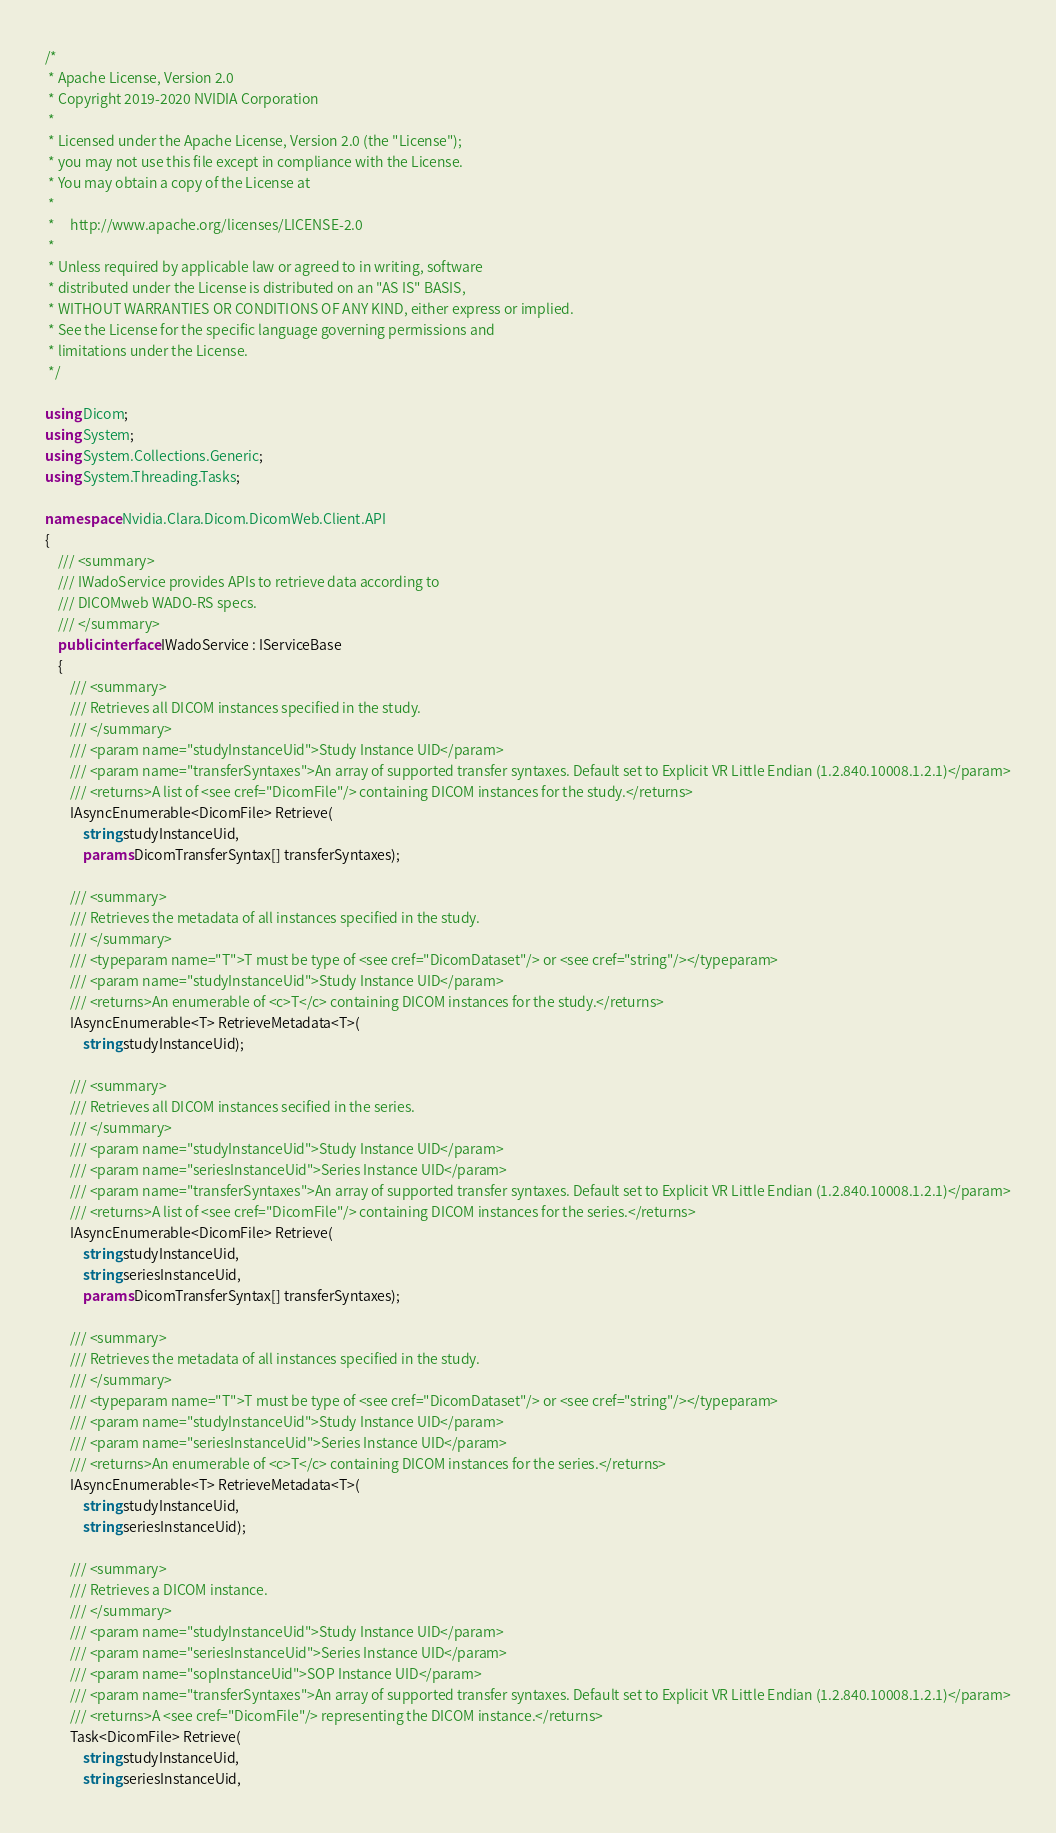<code> <loc_0><loc_0><loc_500><loc_500><_C#_>/*
 * Apache License, Version 2.0
 * Copyright 2019-2020 NVIDIA Corporation
 *
 * Licensed under the Apache License, Version 2.0 (the "License");
 * you may not use this file except in compliance with the License.
 * You may obtain a copy of the License at
 *
 *     http://www.apache.org/licenses/LICENSE-2.0
 *
 * Unless required by applicable law or agreed to in writing, software
 * distributed under the License is distributed on an "AS IS" BASIS,
 * WITHOUT WARRANTIES OR CONDITIONS OF ANY KIND, either express or implied.
 * See the License for the specific language governing permissions and
 * limitations under the License.
 */

using Dicom;
using System;
using System.Collections.Generic;
using System.Threading.Tasks;

namespace Nvidia.Clara.Dicom.DicomWeb.Client.API
{
    /// <summary>
    /// IWadoService provides APIs to retrieve data according to
    /// DICOMweb WADO-RS specs.
    /// </summary>
    public interface IWadoService : IServiceBase
    {
        /// <summary>
        /// Retrieves all DICOM instances specified in the study.
        /// </summary>
        /// <param name="studyInstanceUid">Study Instance UID</param>
        /// <param name="transferSyntaxes">An array of supported transfer syntaxes. Default set to Explicit VR Little Endian (1.2.840.10008.1.2.1)</param>
        /// <returns>A list of <see cref="DicomFile"/> containing DICOM instances for the study.</returns>
        IAsyncEnumerable<DicomFile> Retrieve(
            string studyInstanceUid,
            params DicomTransferSyntax[] transferSyntaxes);

        /// <summary>
        /// Retrieves the metadata of all instances specified in the study.
        /// </summary>
        /// <typeparam name="T">T must be type of <see cref="DicomDataset"/> or <see cref="string"/></typeparam>
        /// <param name="studyInstanceUid">Study Instance UID</param>
        /// <returns>An enumerable of <c>T</c> containing DICOM instances for the study.</returns>
        IAsyncEnumerable<T> RetrieveMetadata<T>(
            string studyInstanceUid);

        /// <summary>
        /// Retrieves all DICOM instances secified in the series.
        /// </summary>
        /// <param name="studyInstanceUid">Study Instance UID</param>
        /// <param name="seriesInstanceUid">Series Instance UID</param>
        /// <param name="transferSyntaxes">An array of supported transfer syntaxes. Default set to Explicit VR Little Endian (1.2.840.10008.1.2.1)</param>
        /// <returns>A list of <see cref="DicomFile"/> containing DICOM instances for the series.</returns>
        IAsyncEnumerable<DicomFile> Retrieve(
            string studyInstanceUid,
            string seriesInstanceUid,
            params DicomTransferSyntax[] transferSyntaxes);

        /// <summary>
        /// Retrieves the metadata of all instances specified in the study.
        /// </summary>
        /// <typeparam name="T">T must be type of <see cref="DicomDataset"/> or <see cref="string"/></typeparam>
        /// <param name="studyInstanceUid">Study Instance UID</param>
        /// <param name="seriesInstanceUid">Series Instance UID</param>
        /// <returns>An enumerable of <c>T</c> containing DICOM instances for the series.</returns>
        IAsyncEnumerable<T> RetrieveMetadata<T>(
            string studyInstanceUid,
            string seriesInstanceUid);

        /// <summary>
        /// Retrieves a DICOM instance.
        /// </summary>
        /// <param name="studyInstanceUid">Study Instance UID</param>
        /// <param name="seriesInstanceUid">Series Instance UID</param>
        /// <param name="sopInstanceUid">SOP Instance UID</param>
        /// <param name="transferSyntaxes">An array of supported transfer syntaxes. Default set to Explicit VR Little Endian (1.2.840.10008.1.2.1)</param>
        /// <returns>A <see cref="DicomFile"/> representing the DICOM instance.</returns>
        Task<DicomFile> Retrieve(
            string studyInstanceUid,
            string seriesInstanceUid,</code> 